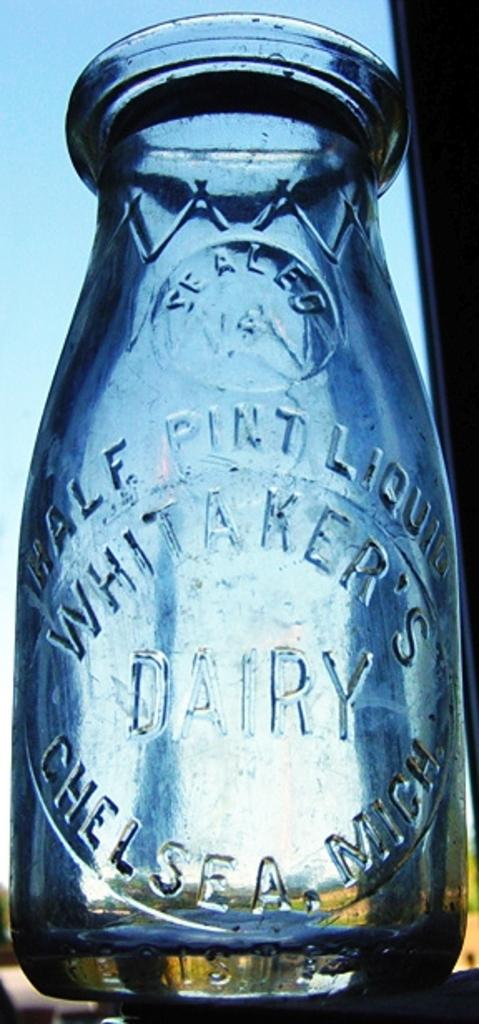<image>
Relay a brief, clear account of the picture shown. a clear jar that says whitaker's dairy chelsea. midh 